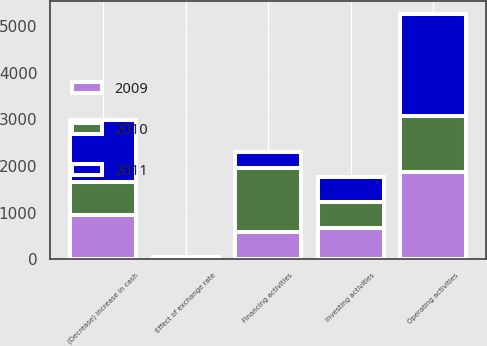Convert chart. <chart><loc_0><loc_0><loc_500><loc_500><stacked_bar_chart><ecel><fcel>Operating activities<fcel>Investing activities<fcel>Financing activities<fcel>Effect of exchange rate<fcel>(Decrease) increase in cash<nl><fcel>2010<fcel>1190<fcel>569<fcel>1357<fcel>13<fcel>723<nl><fcel>2011<fcel>2206<fcel>540<fcel>348<fcel>10<fcel>1328<nl><fcel>2009<fcel>1877<fcel>657<fcel>591<fcel>19<fcel>940<nl></chart> 